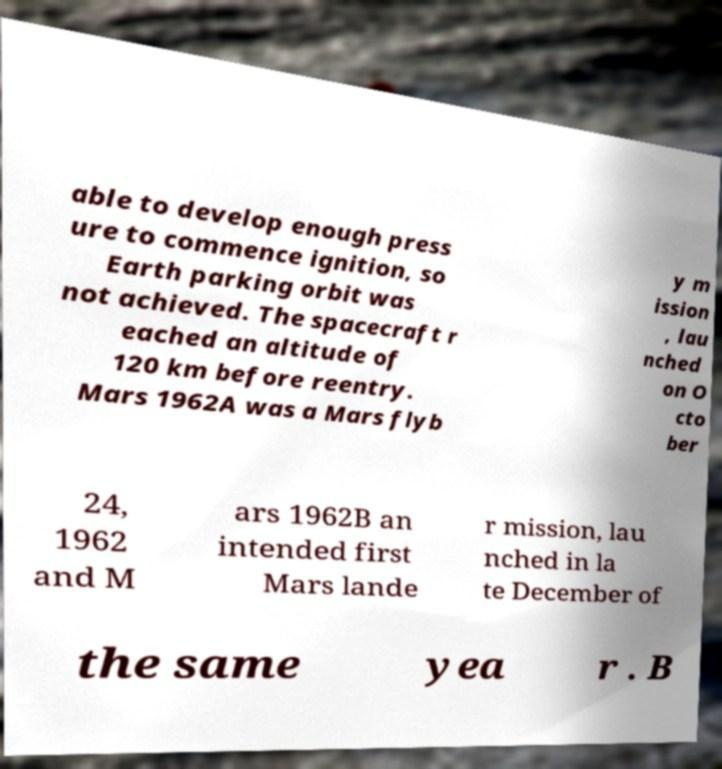For documentation purposes, I need the text within this image transcribed. Could you provide that? able to develop enough press ure to commence ignition, so Earth parking orbit was not achieved. The spacecraft r eached an altitude of 120 km before reentry. Mars 1962A was a Mars flyb y m ission , lau nched on O cto ber 24, 1962 and M ars 1962B an intended first Mars lande r mission, lau nched in la te December of the same yea r . B 